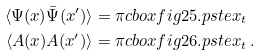Convert formula to latex. <formula><loc_0><loc_0><loc_500><loc_500>\langle \Psi ( x ) \bar { \Psi } ( x ^ { \prime } ) \rangle & = \pi c b o x { f i g 2 5 . p s t e x _ { t } } \\ \langle A ( x ) A ( x ^ { \prime } ) \rangle & = \pi c b o x { f i g 2 6 . p s t e x _ { t } } \, .</formula> 